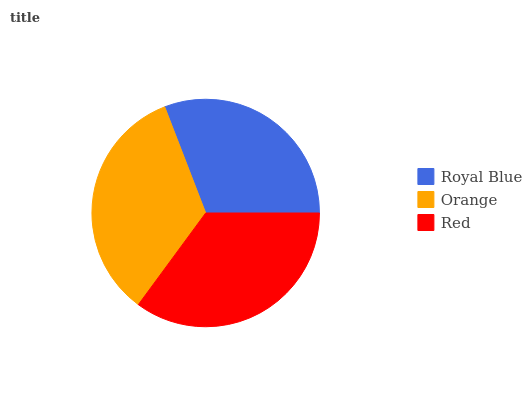Is Royal Blue the minimum?
Answer yes or no. Yes. Is Red the maximum?
Answer yes or no. Yes. Is Orange the minimum?
Answer yes or no. No. Is Orange the maximum?
Answer yes or no. No. Is Orange greater than Royal Blue?
Answer yes or no. Yes. Is Royal Blue less than Orange?
Answer yes or no. Yes. Is Royal Blue greater than Orange?
Answer yes or no. No. Is Orange less than Royal Blue?
Answer yes or no. No. Is Orange the high median?
Answer yes or no. Yes. Is Orange the low median?
Answer yes or no. Yes. Is Red the high median?
Answer yes or no. No. Is Red the low median?
Answer yes or no. No. 